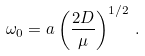Convert formula to latex. <formula><loc_0><loc_0><loc_500><loc_500>\omega _ { 0 } = a \left ( \frac { 2 D } { \mu } \right ) ^ { 1 / 2 } \, .</formula> 